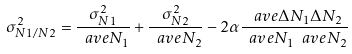<formula> <loc_0><loc_0><loc_500><loc_500>\sigma _ { N 1 / N 2 } ^ { 2 } = \frac { \sigma _ { N 1 } ^ { 2 } } { \ a v e { N _ { 1 } } } + \frac { \sigma _ { N 2 } ^ { 2 } } { \ a v e { N _ { 2 } } } - 2 \alpha \frac { \ a v e { \Delta N _ { 1 } \Delta N _ { 2 } } } { \ a v e { N _ { 1 } } \ a v e { N _ { 2 } } }</formula> 